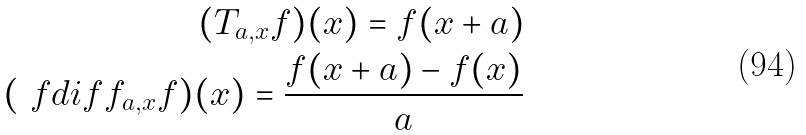Convert formula to latex. <formula><loc_0><loc_0><loc_500><loc_500>( T _ { a , x } f ) ( x ) = f ( x + a ) \\ ( \ f d i f f _ { a , x } f ) ( x ) = \frac { f ( x + a ) - f ( x ) } { a }</formula> 